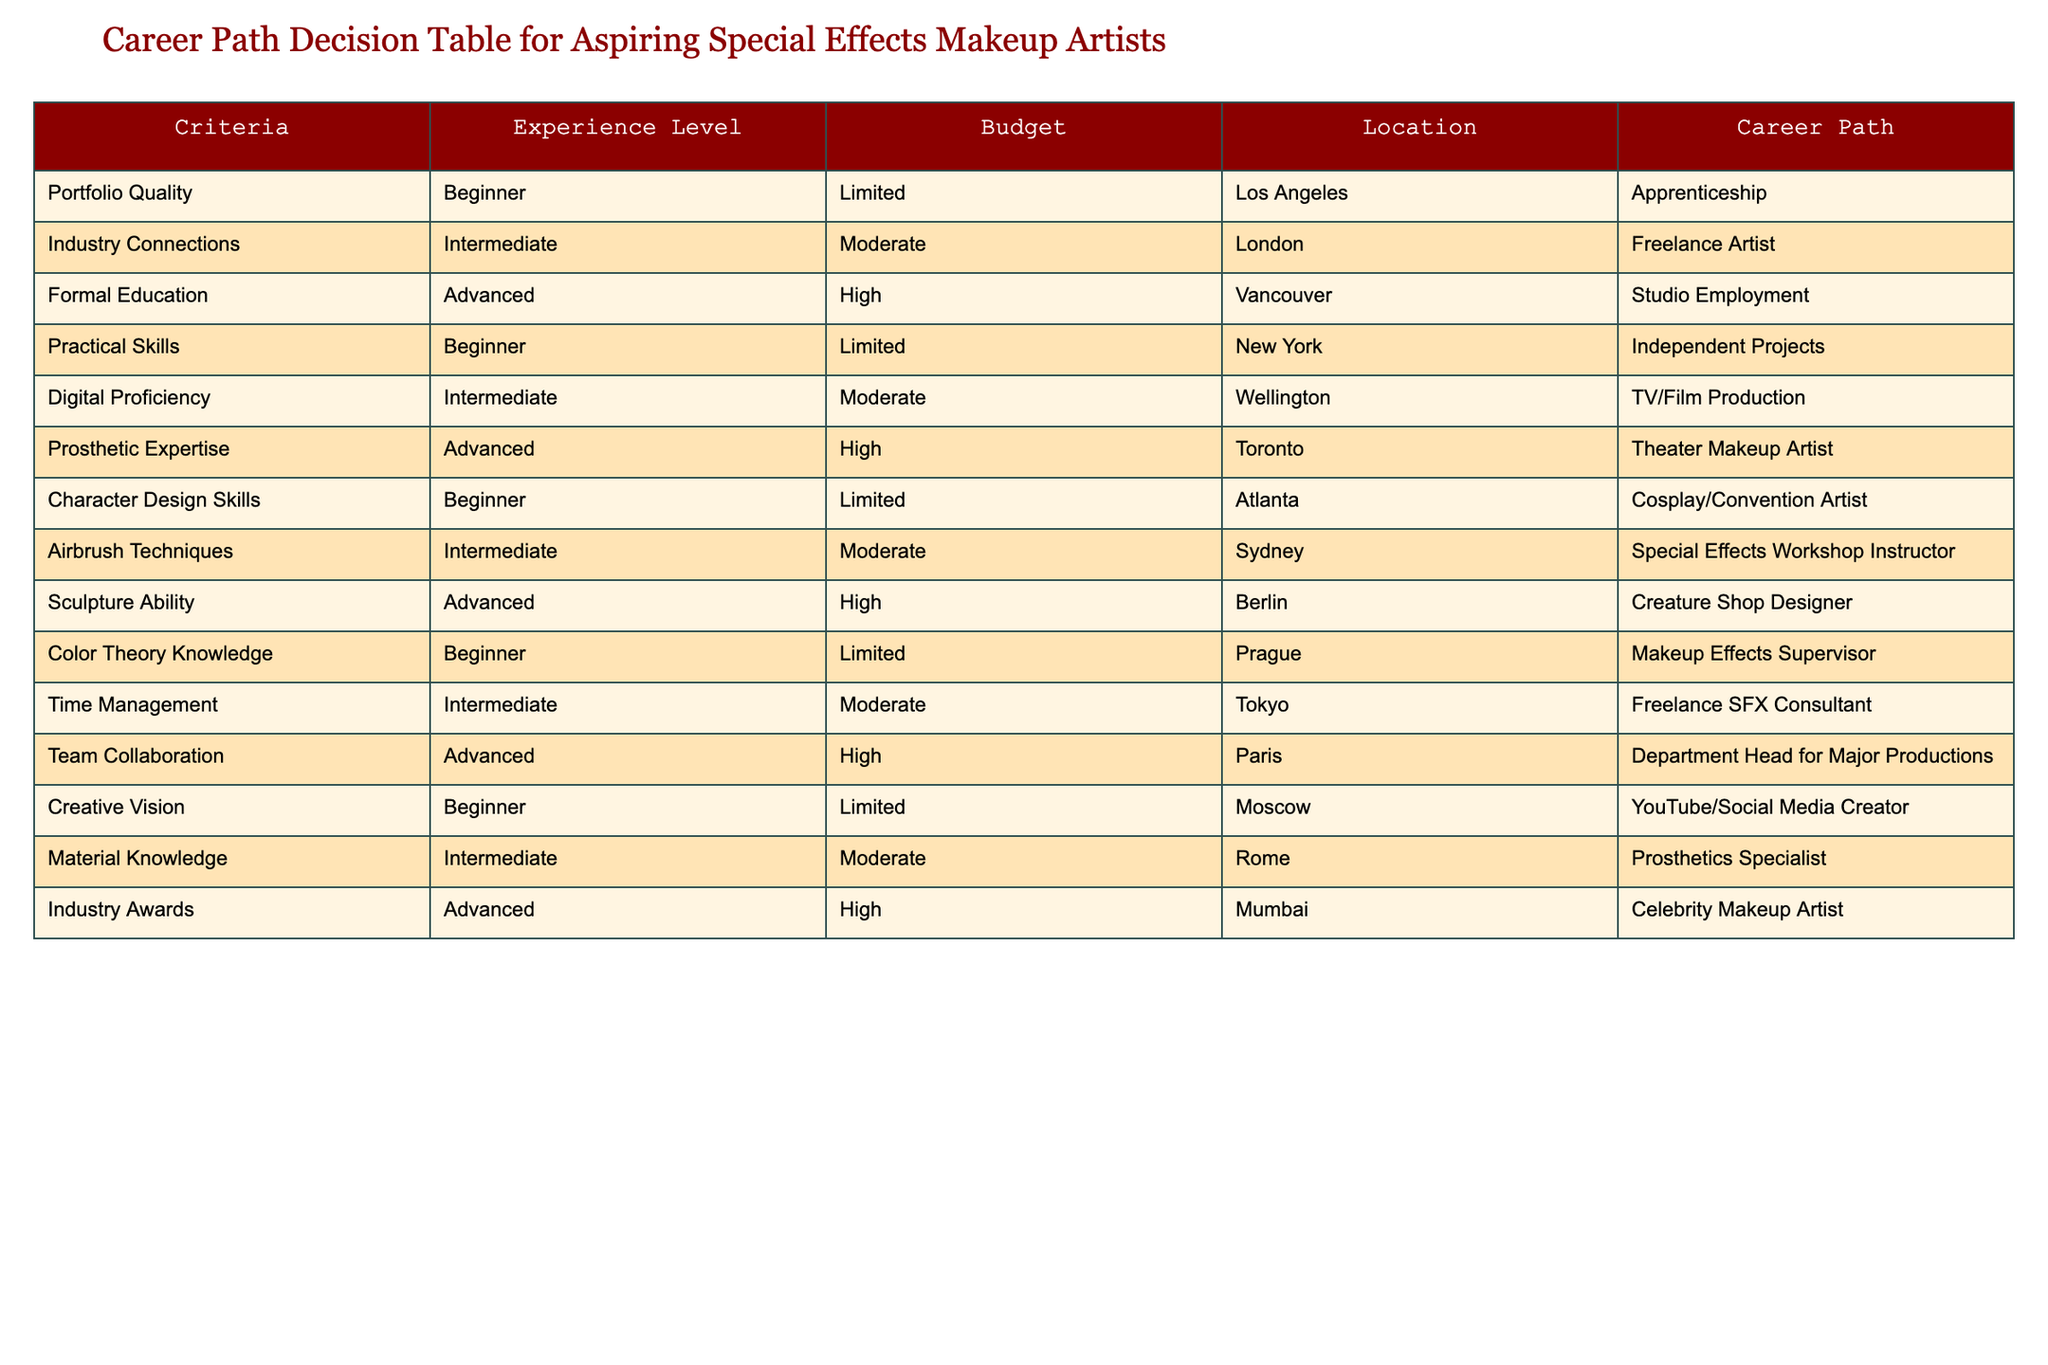What is the career path for an aspiring special effects makeup artist with advanced prosthetic expertise? According to the table, an individual with advanced prosthetic expertise would pursue a career as a theater makeup artist located in Toronto.
Answer: Theater makeup artist Which city offers the career path of a freelance artist for someone with intermediate industry connections? The table indicates that individuals with intermediate industry connections can become freelance artists in London.
Answer: London What is the budget requirement for a beginner aiming to become a makeup effects supervisor? The table specifies that the budget for a beginner aiming to become a makeup effects supervisor, located in Prague, is limited.
Answer: Limited Is it true that one can become a celebrity makeup artist with advanced industry awards in Mumbai? The data in the table confirms that having advanced industry awards leads to a career as a celebrity makeup artist in Mumbai. Therefore, the statement is true.
Answer: Yes What is the difference in budget between pursuing independent projects and character design skills? From the table, pursuing independent projects requires a limited budget, while character design skills also require a limited budget. Thus, the difference is 0, as they both fall into the same budget category.
Answer: 0 How many career paths require an advanced experience level? The table lists three career paths that require an advanced experience level: studio employment, theater makeup artist, and celebrity makeup artist. Therefore, there are three such paths.
Answer: 3 Which career path has the lowest experience level but also requires a limited budget? The data indicates that both the careers of a cosplay/convention artist and YouTube/social media creator have a beginner experience level and require a limited budget.
Answer: Cosplay/convention artist and YouTube/social media creator If someone has intermediate digital proficiency and moderate budget, which career paths are suitable for them? The table shows two suitable career paths for someone with intermediate digital proficiency and moderate budget: TV/Film production and prosthetics specialist.
Answer: TV/Film production and prosthetics specialist What career path can someone pursue with advanced time management skills and a high budget? Based on the table, an individual with advanced time management skills and a high budget can pursue the career path of a department head for major productions in Paris.
Answer: Department head for major productions 